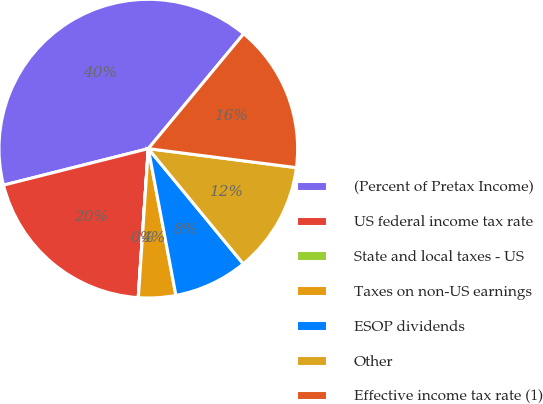<chart> <loc_0><loc_0><loc_500><loc_500><pie_chart><fcel>(Percent of Pretax Income)<fcel>US federal income tax rate<fcel>State and local taxes - US<fcel>Taxes on non-US earnings<fcel>ESOP dividends<fcel>Other<fcel>Effective income tax rate (1)<nl><fcel>39.96%<fcel>19.99%<fcel>0.02%<fcel>4.02%<fcel>8.01%<fcel>12.0%<fcel>16.0%<nl></chart> 